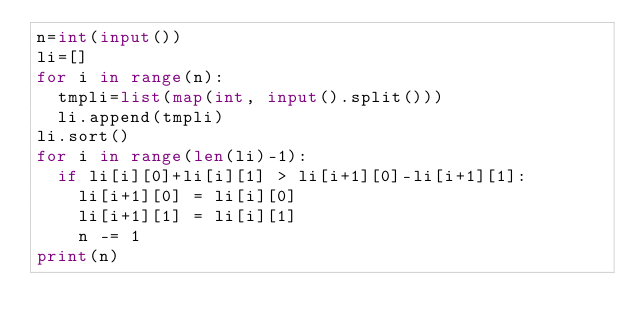<code> <loc_0><loc_0><loc_500><loc_500><_Python_>n=int(input())
li=[]
for i in range(n):
  tmpli=list(map(int, input().split()))
  li.append(tmpli)
li.sort()
for i in range(len(li)-1):
  if li[i][0]+li[i][1] > li[i+1][0]-li[i+1][1]:
    li[i+1][0] = li[i][0]
    li[i+1][1] = li[i][1]
    n -= 1
print(n)</code> 